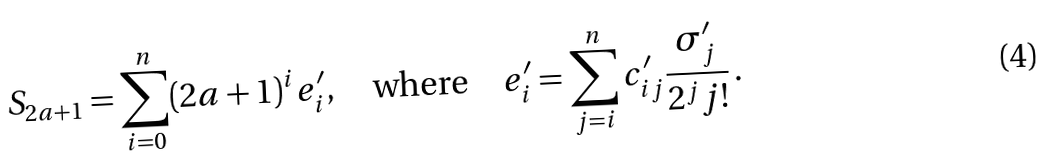<formula> <loc_0><loc_0><loc_500><loc_500>S _ { 2 a + 1 } = \sum _ { i = 0 } ^ { n } ( 2 a + 1 ) ^ { i } e ^ { \prime } _ { i } , \quad \text {where} \quad e ^ { \prime } _ { i } = \sum _ { j = i } ^ { n } c ^ { \prime } _ { i j } \frac { \sigma ^ { \prime } _ { j } } { 2 ^ { j } j ! } \, .</formula> 